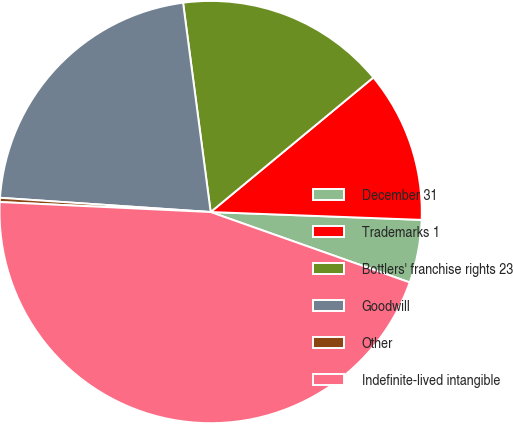<chart> <loc_0><loc_0><loc_500><loc_500><pie_chart><fcel>December 31<fcel>Trademarks 1<fcel>Bottlers' franchise rights 23<fcel>Goodwill<fcel>Other<fcel>Indefinite-lived intangible<nl><fcel>4.82%<fcel>11.59%<fcel>16.09%<fcel>21.84%<fcel>0.32%<fcel>45.35%<nl></chart> 